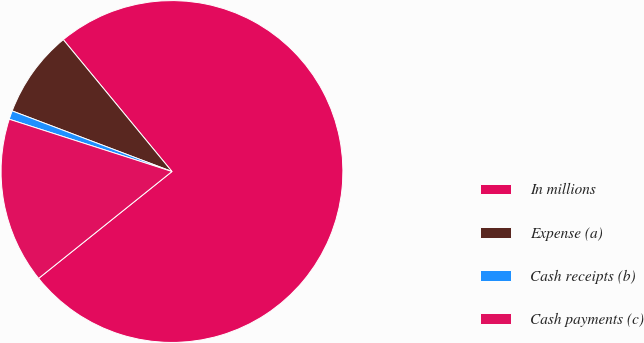Convert chart. <chart><loc_0><loc_0><loc_500><loc_500><pie_chart><fcel>In millions<fcel>Expense (a)<fcel>Cash receipts (b)<fcel>Cash payments (c)<nl><fcel>75.22%<fcel>8.26%<fcel>0.82%<fcel>15.7%<nl></chart> 